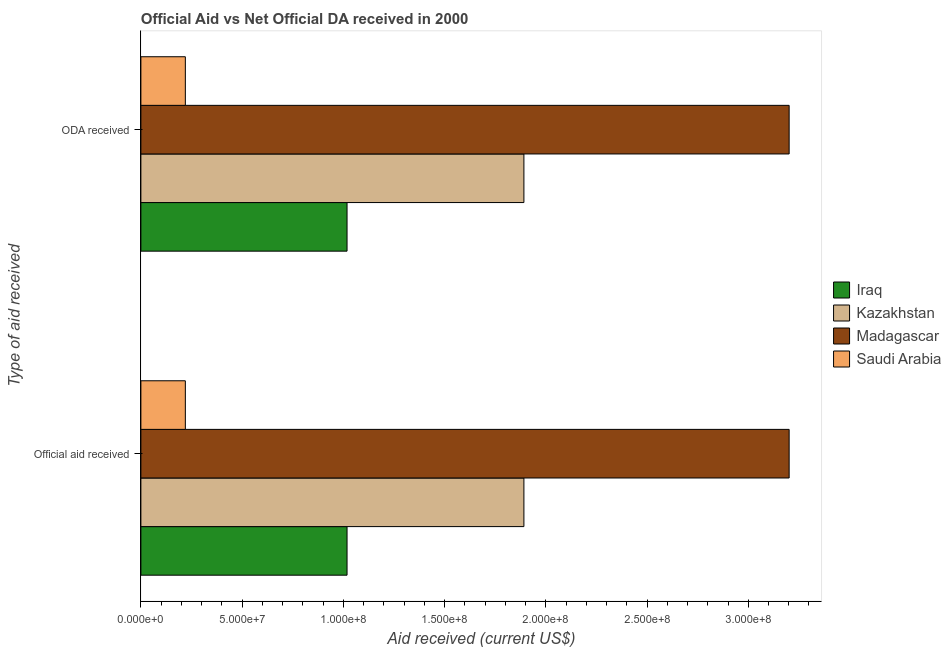How many different coloured bars are there?
Your answer should be very brief. 4. Are the number of bars on each tick of the Y-axis equal?
Provide a succinct answer. Yes. What is the label of the 1st group of bars from the top?
Provide a short and direct response. ODA received. What is the oda received in Saudi Arabia?
Offer a terse response. 2.20e+07. Across all countries, what is the maximum oda received?
Provide a short and direct response. 3.20e+08. Across all countries, what is the minimum oda received?
Provide a short and direct response. 2.20e+07. In which country was the official aid received maximum?
Provide a succinct answer. Madagascar. In which country was the official aid received minimum?
Keep it short and to the point. Saudi Arabia. What is the total oda received in the graph?
Your answer should be very brief. 6.33e+08. What is the difference between the official aid received in Iraq and that in Kazakhstan?
Provide a short and direct response. -8.74e+07. What is the difference between the oda received in Iraq and the official aid received in Kazakhstan?
Keep it short and to the point. -8.74e+07. What is the average official aid received per country?
Your answer should be very brief. 1.58e+08. What is the difference between the oda received and official aid received in Kazakhstan?
Ensure brevity in your answer.  0. What is the ratio of the official aid received in Iraq to that in Saudi Arabia?
Give a very brief answer. 4.64. Is the official aid received in Saudi Arabia less than that in Kazakhstan?
Give a very brief answer. Yes. In how many countries, is the oda received greater than the average oda received taken over all countries?
Your response must be concise. 2. What does the 3rd bar from the top in Official aid received represents?
Keep it short and to the point. Kazakhstan. What does the 2nd bar from the bottom in ODA received represents?
Provide a short and direct response. Kazakhstan. How many bars are there?
Your response must be concise. 8. Are all the bars in the graph horizontal?
Provide a succinct answer. Yes. How many countries are there in the graph?
Give a very brief answer. 4. What is the difference between two consecutive major ticks on the X-axis?
Provide a short and direct response. 5.00e+07. Are the values on the major ticks of X-axis written in scientific E-notation?
Provide a short and direct response. Yes. Does the graph contain any zero values?
Provide a short and direct response. No. Does the graph contain grids?
Provide a succinct answer. No. How are the legend labels stacked?
Make the answer very short. Vertical. What is the title of the graph?
Offer a very short reply. Official Aid vs Net Official DA received in 2000 . What is the label or title of the X-axis?
Provide a succinct answer. Aid received (current US$). What is the label or title of the Y-axis?
Provide a short and direct response. Type of aid received. What is the Aid received (current US$) of Iraq in Official aid received?
Keep it short and to the point. 1.02e+08. What is the Aid received (current US$) of Kazakhstan in Official aid received?
Your answer should be very brief. 1.89e+08. What is the Aid received (current US$) in Madagascar in Official aid received?
Keep it short and to the point. 3.20e+08. What is the Aid received (current US$) in Saudi Arabia in Official aid received?
Make the answer very short. 2.20e+07. What is the Aid received (current US$) of Iraq in ODA received?
Offer a terse response. 1.02e+08. What is the Aid received (current US$) of Kazakhstan in ODA received?
Your answer should be very brief. 1.89e+08. What is the Aid received (current US$) in Madagascar in ODA received?
Offer a very short reply. 3.20e+08. What is the Aid received (current US$) in Saudi Arabia in ODA received?
Make the answer very short. 2.20e+07. Across all Type of aid received, what is the maximum Aid received (current US$) in Iraq?
Offer a terse response. 1.02e+08. Across all Type of aid received, what is the maximum Aid received (current US$) in Kazakhstan?
Ensure brevity in your answer.  1.89e+08. Across all Type of aid received, what is the maximum Aid received (current US$) of Madagascar?
Provide a short and direct response. 3.20e+08. Across all Type of aid received, what is the maximum Aid received (current US$) in Saudi Arabia?
Keep it short and to the point. 2.20e+07. Across all Type of aid received, what is the minimum Aid received (current US$) in Iraq?
Your response must be concise. 1.02e+08. Across all Type of aid received, what is the minimum Aid received (current US$) of Kazakhstan?
Offer a terse response. 1.89e+08. Across all Type of aid received, what is the minimum Aid received (current US$) of Madagascar?
Offer a terse response. 3.20e+08. Across all Type of aid received, what is the minimum Aid received (current US$) of Saudi Arabia?
Offer a terse response. 2.20e+07. What is the total Aid received (current US$) in Iraq in the graph?
Offer a terse response. 2.04e+08. What is the total Aid received (current US$) in Kazakhstan in the graph?
Keep it short and to the point. 3.78e+08. What is the total Aid received (current US$) in Madagascar in the graph?
Your answer should be very brief. 6.40e+08. What is the total Aid received (current US$) in Saudi Arabia in the graph?
Your answer should be very brief. 4.39e+07. What is the difference between the Aid received (current US$) of Iraq in Official aid received and that in ODA received?
Your answer should be very brief. 0. What is the difference between the Aid received (current US$) of Iraq in Official aid received and the Aid received (current US$) of Kazakhstan in ODA received?
Your response must be concise. -8.74e+07. What is the difference between the Aid received (current US$) in Iraq in Official aid received and the Aid received (current US$) in Madagascar in ODA received?
Offer a very short reply. -2.18e+08. What is the difference between the Aid received (current US$) of Iraq in Official aid received and the Aid received (current US$) of Saudi Arabia in ODA received?
Keep it short and to the point. 7.99e+07. What is the difference between the Aid received (current US$) in Kazakhstan in Official aid received and the Aid received (current US$) in Madagascar in ODA received?
Your answer should be very brief. -1.31e+08. What is the difference between the Aid received (current US$) in Kazakhstan in Official aid received and the Aid received (current US$) in Saudi Arabia in ODA received?
Make the answer very short. 1.67e+08. What is the difference between the Aid received (current US$) of Madagascar in Official aid received and the Aid received (current US$) of Saudi Arabia in ODA received?
Keep it short and to the point. 2.98e+08. What is the average Aid received (current US$) of Iraq per Type of aid received?
Offer a terse response. 1.02e+08. What is the average Aid received (current US$) of Kazakhstan per Type of aid received?
Give a very brief answer. 1.89e+08. What is the average Aid received (current US$) in Madagascar per Type of aid received?
Your answer should be very brief. 3.20e+08. What is the average Aid received (current US$) in Saudi Arabia per Type of aid received?
Provide a short and direct response. 2.20e+07. What is the difference between the Aid received (current US$) of Iraq and Aid received (current US$) of Kazakhstan in Official aid received?
Your response must be concise. -8.74e+07. What is the difference between the Aid received (current US$) of Iraq and Aid received (current US$) of Madagascar in Official aid received?
Offer a terse response. -2.18e+08. What is the difference between the Aid received (current US$) in Iraq and Aid received (current US$) in Saudi Arabia in Official aid received?
Make the answer very short. 7.99e+07. What is the difference between the Aid received (current US$) of Kazakhstan and Aid received (current US$) of Madagascar in Official aid received?
Ensure brevity in your answer.  -1.31e+08. What is the difference between the Aid received (current US$) in Kazakhstan and Aid received (current US$) in Saudi Arabia in Official aid received?
Provide a short and direct response. 1.67e+08. What is the difference between the Aid received (current US$) of Madagascar and Aid received (current US$) of Saudi Arabia in Official aid received?
Your response must be concise. 2.98e+08. What is the difference between the Aid received (current US$) in Iraq and Aid received (current US$) in Kazakhstan in ODA received?
Your answer should be very brief. -8.74e+07. What is the difference between the Aid received (current US$) of Iraq and Aid received (current US$) of Madagascar in ODA received?
Provide a succinct answer. -2.18e+08. What is the difference between the Aid received (current US$) of Iraq and Aid received (current US$) of Saudi Arabia in ODA received?
Keep it short and to the point. 7.99e+07. What is the difference between the Aid received (current US$) of Kazakhstan and Aid received (current US$) of Madagascar in ODA received?
Offer a very short reply. -1.31e+08. What is the difference between the Aid received (current US$) in Kazakhstan and Aid received (current US$) in Saudi Arabia in ODA received?
Give a very brief answer. 1.67e+08. What is the difference between the Aid received (current US$) in Madagascar and Aid received (current US$) in Saudi Arabia in ODA received?
Offer a very short reply. 2.98e+08. What is the ratio of the Aid received (current US$) in Iraq in Official aid received to that in ODA received?
Your response must be concise. 1. What is the difference between the highest and the second highest Aid received (current US$) in Iraq?
Make the answer very short. 0. What is the difference between the highest and the second highest Aid received (current US$) in Madagascar?
Make the answer very short. 0. What is the difference between the highest and the second highest Aid received (current US$) of Saudi Arabia?
Keep it short and to the point. 0. What is the difference between the highest and the lowest Aid received (current US$) in Madagascar?
Your answer should be compact. 0. 